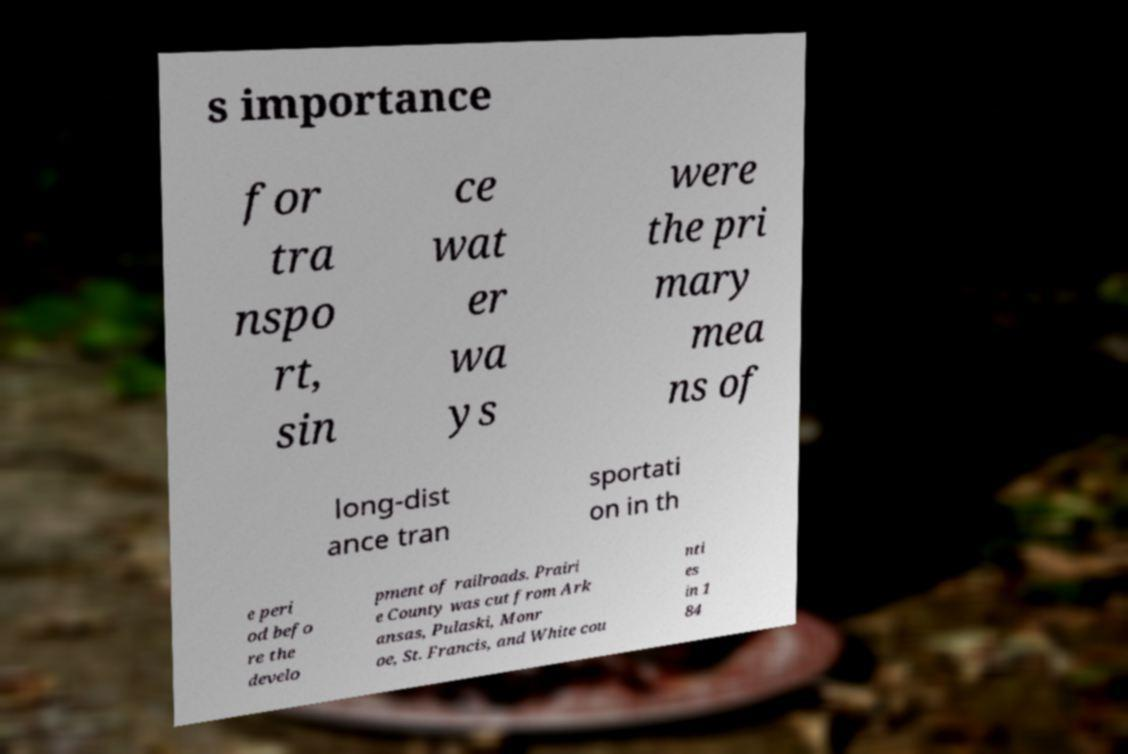What messages or text are displayed in this image? I need them in a readable, typed format. s importance for tra nspo rt, sin ce wat er wa ys were the pri mary mea ns of long-dist ance tran sportati on in th e peri od befo re the develo pment of railroads. Prairi e County was cut from Ark ansas, Pulaski, Monr oe, St. Francis, and White cou nti es in 1 84 